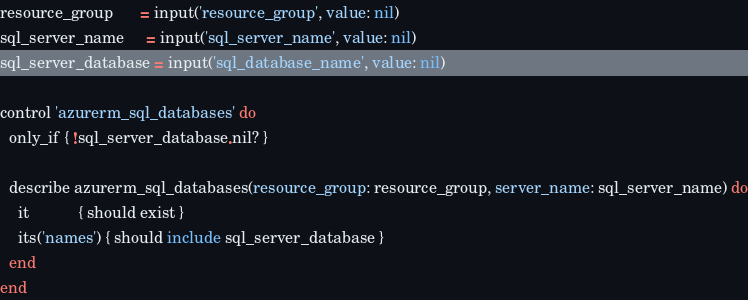Convert code to text. <code><loc_0><loc_0><loc_500><loc_500><_Ruby_>resource_group      = input('resource_group', value: nil)
sql_server_name     = input('sql_server_name', value: nil)
sql_server_database = input('sql_database_name', value: nil)

control 'azurerm_sql_databases' do
  only_if { !sql_server_database.nil? }

  describe azurerm_sql_databases(resource_group: resource_group, server_name: sql_server_name) do
    it           { should exist }
    its('names') { should include sql_server_database }
  end
end
</code> 